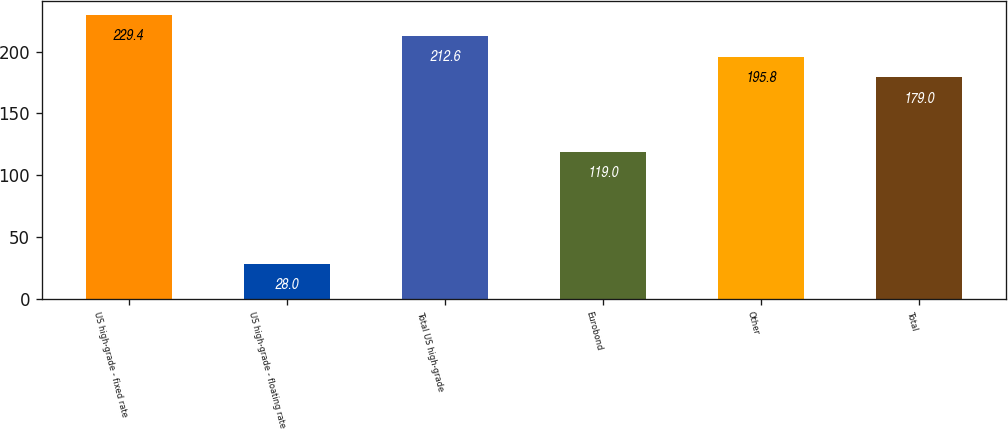Convert chart. <chart><loc_0><loc_0><loc_500><loc_500><bar_chart><fcel>US high-grade - fixed rate<fcel>US high-grade - floating rate<fcel>Total US high-grade<fcel>Eurobond<fcel>Other<fcel>Total<nl><fcel>229.4<fcel>28<fcel>212.6<fcel>119<fcel>195.8<fcel>179<nl></chart> 